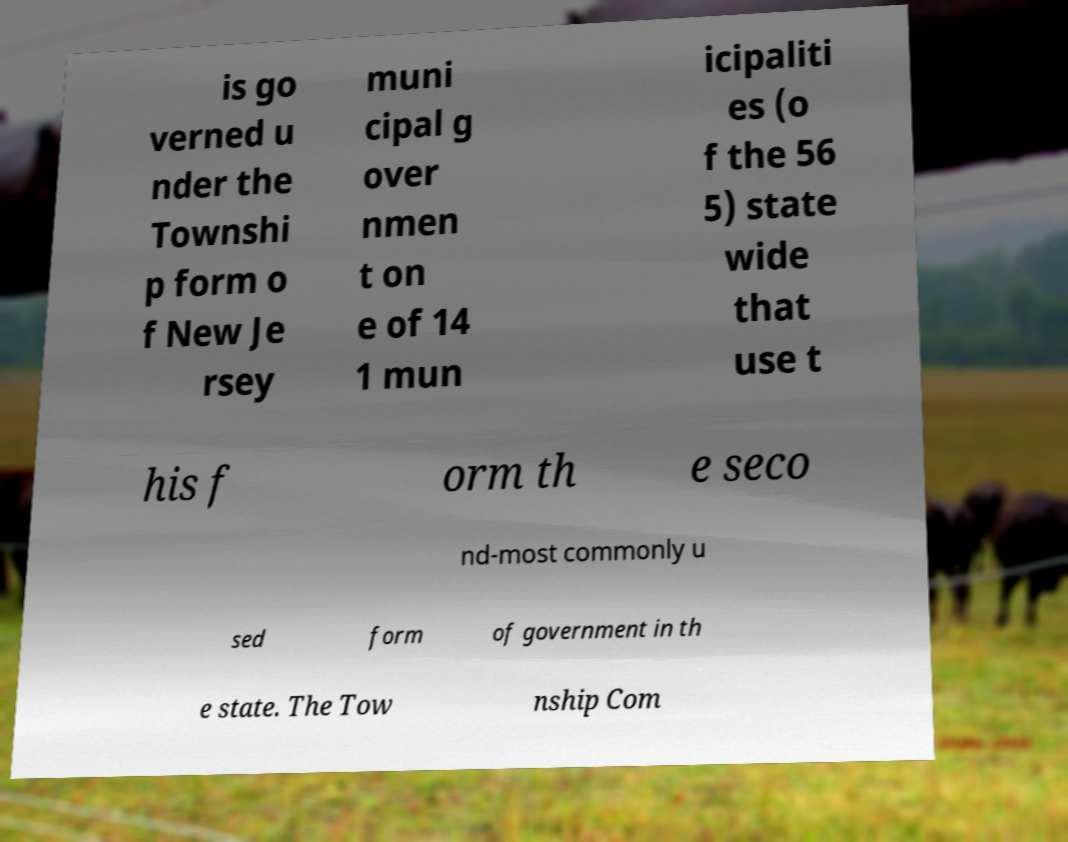Could you extract and type out the text from this image? is go verned u nder the Townshi p form o f New Je rsey muni cipal g over nmen t on e of 14 1 mun icipaliti es (o f the 56 5) state wide that use t his f orm th e seco nd-most commonly u sed form of government in th e state. The Tow nship Com 